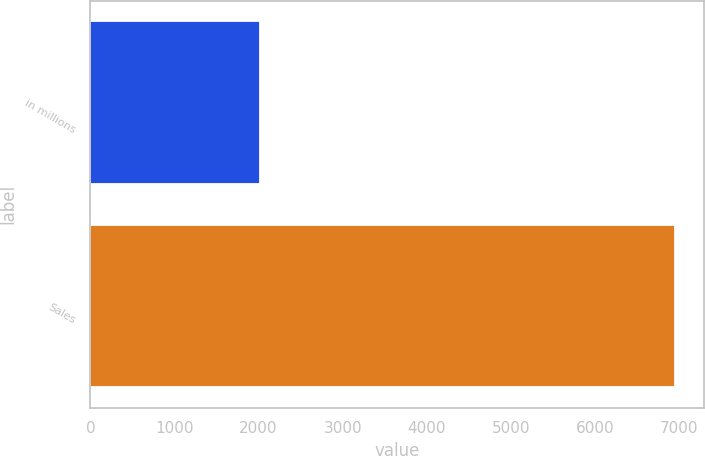<chart> <loc_0><loc_0><loc_500><loc_500><bar_chart><fcel>in millions<fcel>Sales<nl><fcel>2012<fcel>6950<nl></chart> 